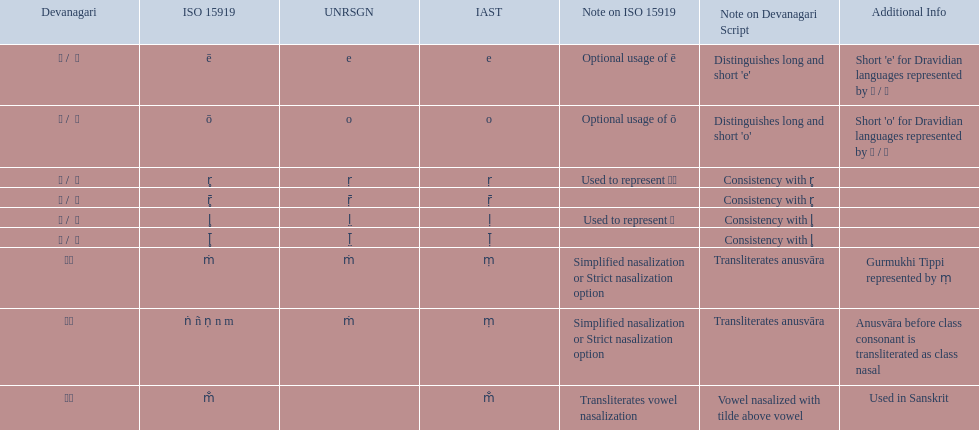What iast is listed before the o? E. 